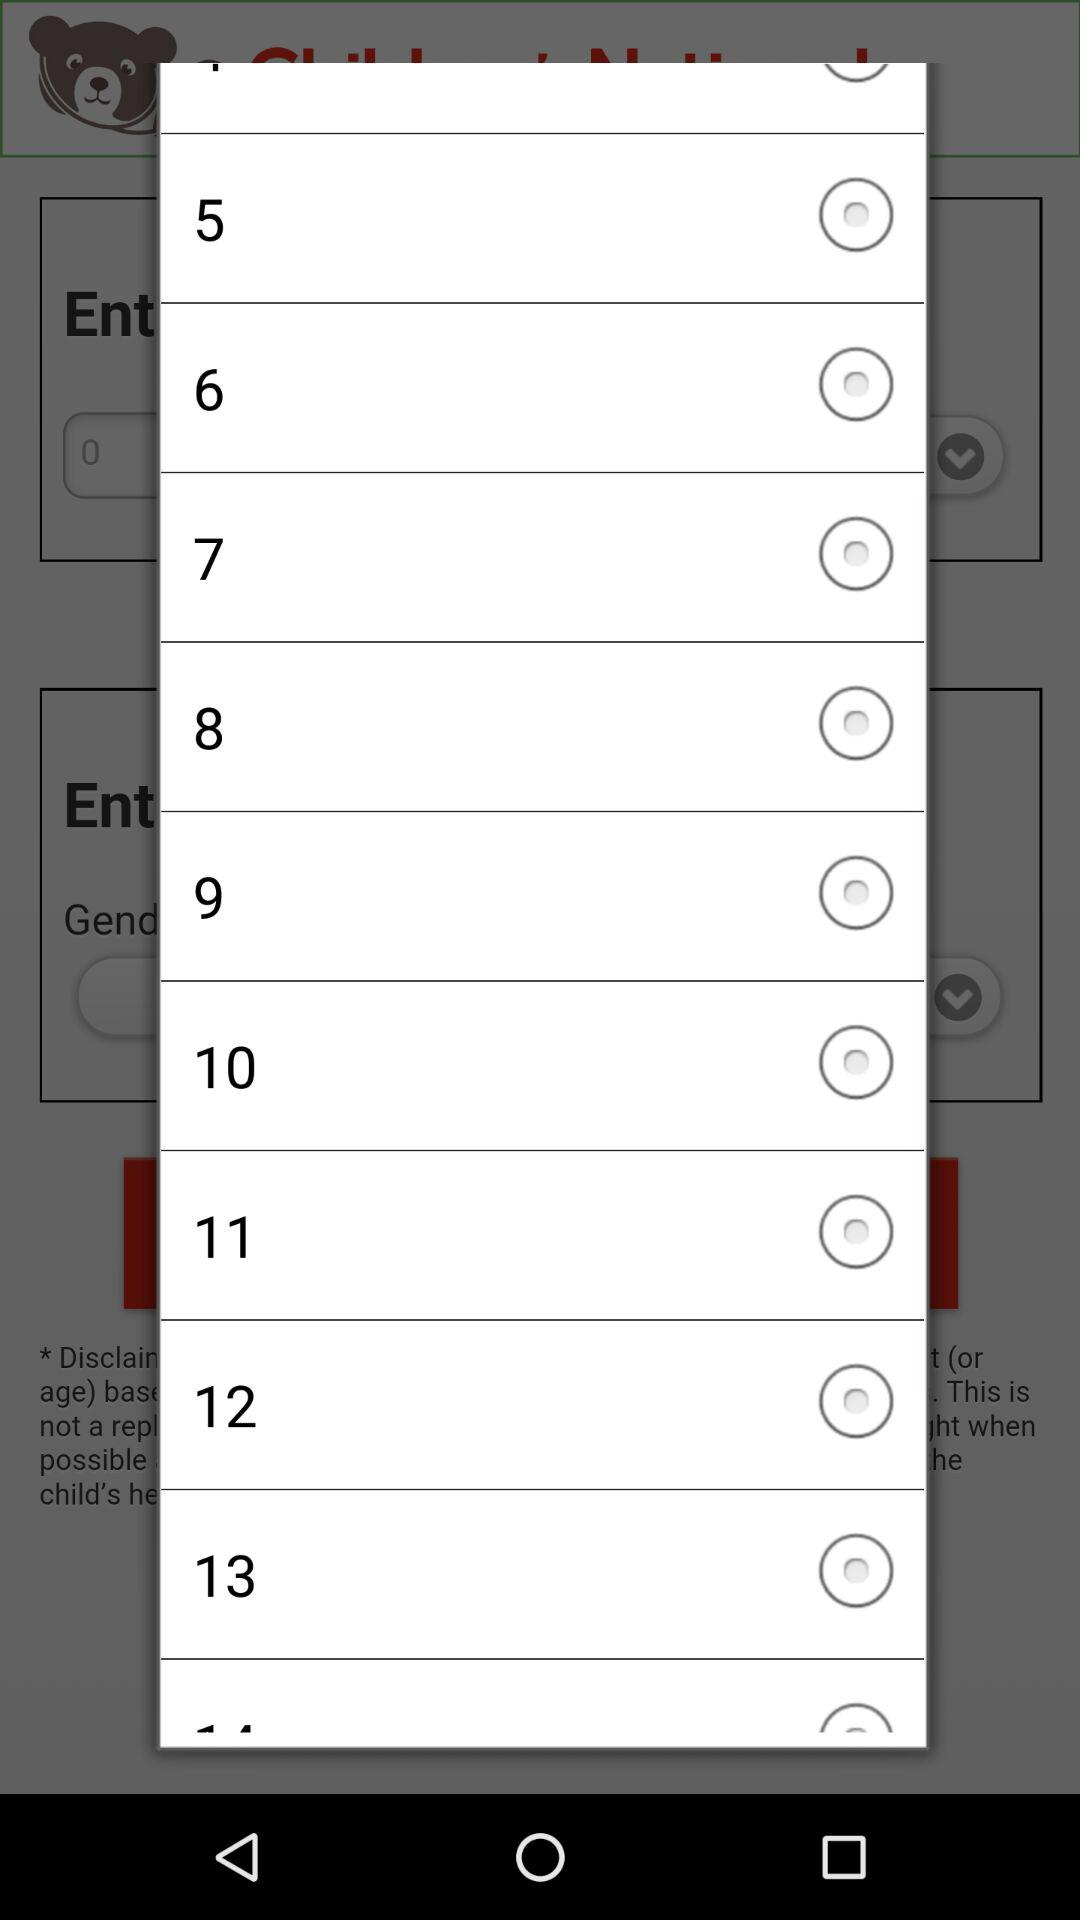Is "5" selected or not? "5" is not selected. 